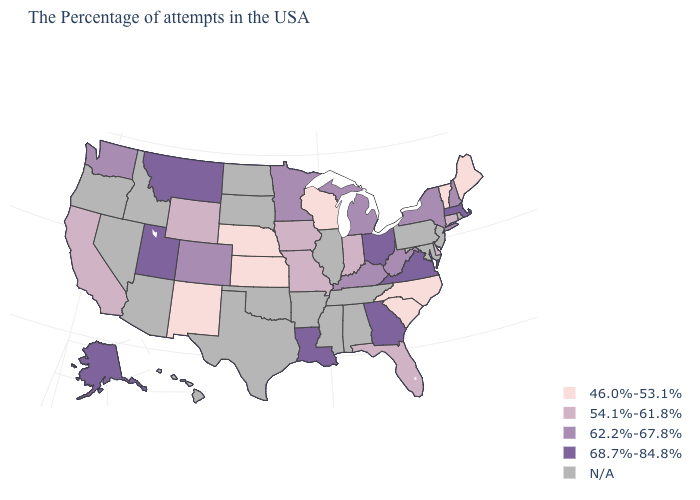What is the value of Connecticut?
Short answer required. 54.1%-61.8%. What is the value of New Mexico?
Concise answer only. 46.0%-53.1%. What is the lowest value in the South?
Give a very brief answer. 46.0%-53.1%. What is the value of Vermont?
Short answer required. 46.0%-53.1%. What is the value of Kansas?
Concise answer only. 46.0%-53.1%. Which states have the highest value in the USA?
Concise answer only. Massachusetts, Virginia, Ohio, Georgia, Louisiana, Utah, Montana, Alaska. Name the states that have a value in the range N/A?
Be succinct. Rhode Island, New Jersey, Maryland, Pennsylvania, Alabama, Tennessee, Illinois, Mississippi, Arkansas, Oklahoma, Texas, South Dakota, North Dakota, Arizona, Idaho, Nevada, Oregon, Hawaii. What is the value of Michigan?
Short answer required. 62.2%-67.8%. What is the value of Florida?
Give a very brief answer. 54.1%-61.8%. What is the highest value in the USA?
Write a very short answer. 68.7%-84.8%. What is the lowest value in the USA?
Write a very short answer. 46.0%-53.1%. What is the value of Massachusetts?
Short answer required. 68.7%-84.8%. Which states hav the highest value in the West?
Short answer required. Utah, Montana, Alaska. 